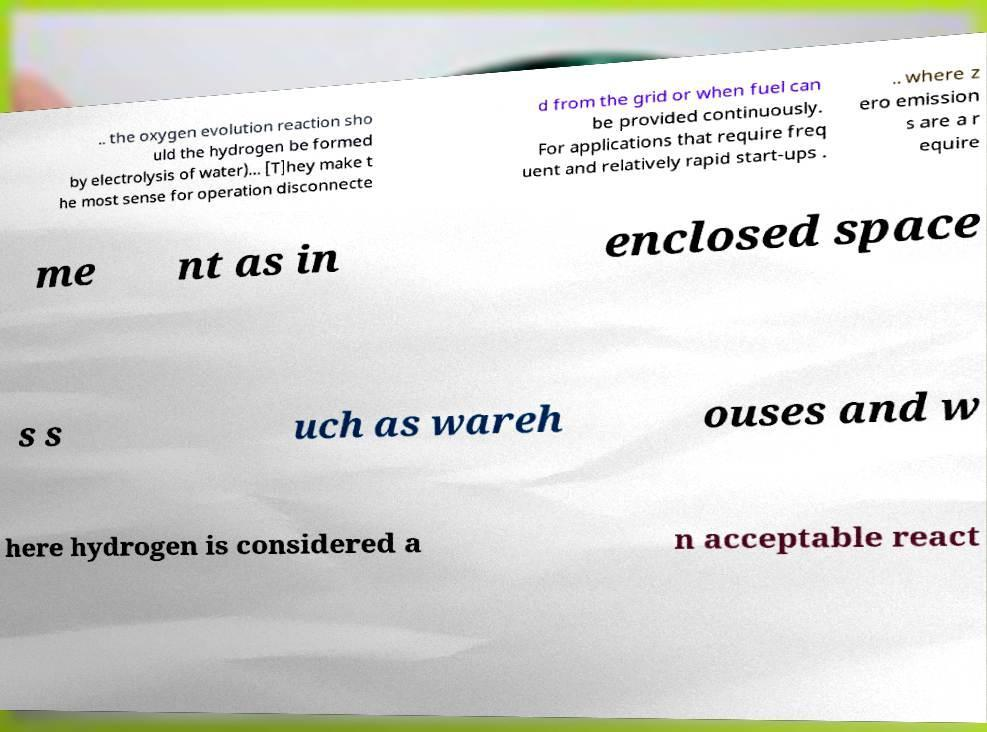What messages or text are displayed in this image? I need them in a readable, typed format. .. the oxygen evolution reaction sho uld the hydrogen be formed by electrolysis of water)... [T]hey make t he most sense for operation disconnecte d from the grid or when fuel can be provided continuously. For applications that require freq uent and relatively rapid start-ups . .. where z ero emission s are a r equire me nt as in enclosed space s s uch as wareh ouses and w here hydrogen is considered a n acceptable react 